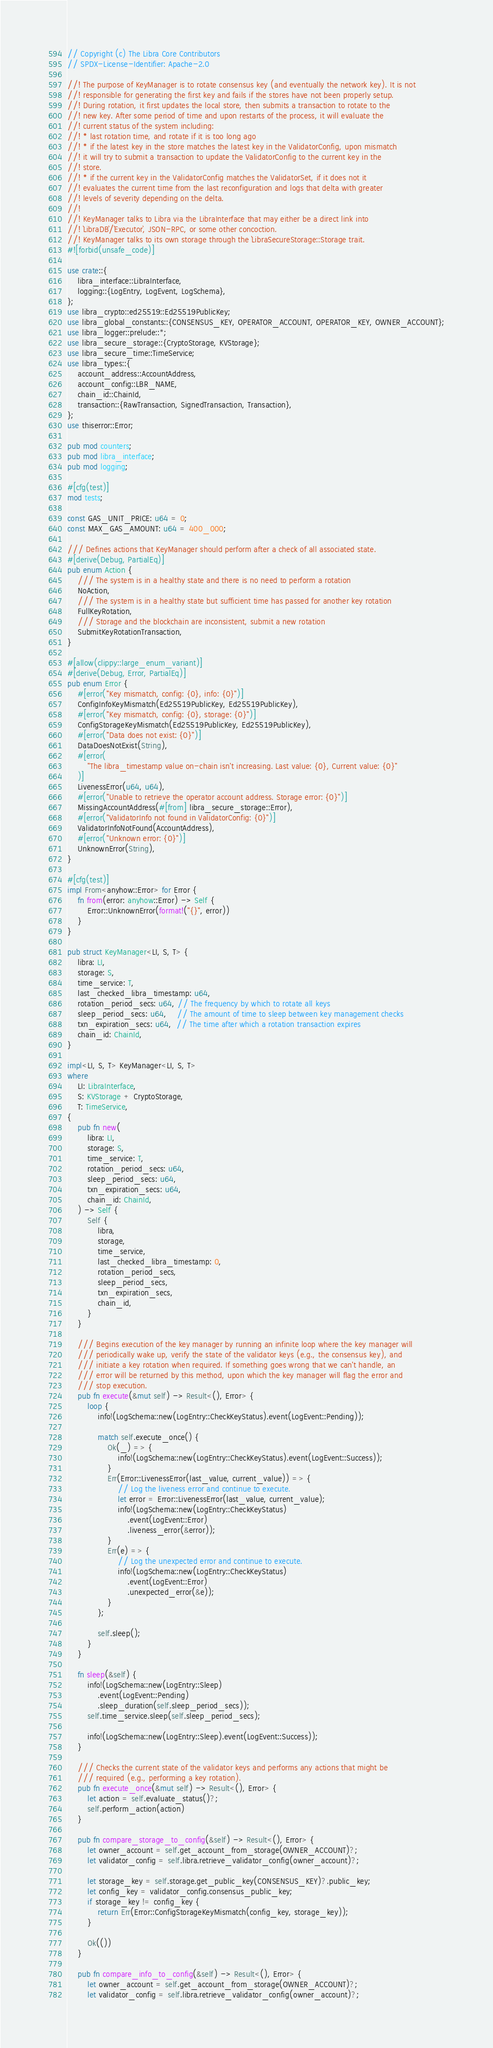<code> <loc_0><loc_0><loc_500><loc_500><_Rust_>// Copyright (c) The Libra Core Contributors
// SPDX-License-Identifier: Apache-2.0

//! The purpose of KeyManager is to rotate consensus key (and eventually the network key). It is not
//! responsible for generating the first key and fails if the stores have not been properly setup.
//! During rotation, it first updates the local store, then submits a transaction to rotate to the
//! new key. After some period of time and upon restarts of the process, it will evaluate the
//! current status of the system including:
//! * last rotation time, and rotate if it is too long ago
//! * if the latest key in the store matches the latest key in the ValidatorConfig, upon mismatch
//! it will try to submit a transaction to update the ValidatorConfig to the current key in the
//! store.
//! * if the current key in the ValidatorConfig matches the ValidatorSet, if it does not it
//! evaluates the current time from the last reconfiguration and logs that delta with greater
//! levels of severity depending on the delta.
//!
//! KeyManager talks to Libra via the LibraInterface that may either be a direct link into
//! `LibraDB`/`Executor`, JSON-RPC, or some other concoction.
//! KeyManager talks to its own storage through the `LibraSecureStorage::Storage trait.
#![forbid(unsafe_code)]

use crate::{
    libra_interface::LibraInterface,
    logging::{LogEntry, LogEvent, LogSchema},
};
use libra_crypto::ed25519::Ed25519PublicKey;
use libra_global_constants::{CONSENSUS_KEY, OPERATOR_ACCOUNT, OPERATOR_KEY, OWNER_ACCOUNT};
use libra_logger::prelude::*;
use libra_secure_storage::{CryptoStorage, KVStorage};
use libra_secure_time::TimeService;
use libra_types::{
    account_address::AccountAddress,
    account_config::LBR_NAME,
    chain_id::ChainId,
    transaction::{RawTransaction, SignedTransaction, Transaction},
};
use thiserror::Error;

pub mod counters;
pub mod libra_interface;
pub mod logging;

#[cfg(test)]
mod tests;

const GAS_UNIT_PRICE: u64 = 0;
const MAX_GAS_AMOUNT: u64 = 400_000;

/// Defines actions that KeyManager should perform after a check of all associated state.
#[derive(Debug, PartialEq)]
pub enum Action {
    /// The system is in a healthy state and there is no need to perform a rotation
    NoAction,
    /// The system is in a healthy state but sufficient time has passed for another key rotation
    FullKeyRotation,
    /// Storage and the blockchain are inconsistent, submit a new rotation
    SubmitKeyRotationTransaction,
}

#[allow(clippy::large_enum_variant)]
#[derive(Debug, Error, PartialEq)]
pub enum Error {
    #[error("Key mismatch, config: {0}, info: {0}")]
    ConfigInfoKeyMismatch(Ed25519PublicKey, Ed25519PublicKey),
    #[error("Key mismatch, config: {0}, storage: {0}")]
    ConfigStorageKeyMismatch(Ed25519PublicKey, Ed25519PublicKey),
    #[error("Data does not exist: {0}")]
    DataDoesNotExist(String),
    #[error(
        "The libra_timestamp value on-chain isn't increasing. Last value: {0}, Current value: {0}"
    )]
    LivenessError(u64, u64),
    #[error("Unable to retrieve the operator account address. Storage error: {0}")]
    MissingAccountAddress(#[from] libra_secure_storage::Error),
    #[error("ValidatorInfo not found in ValidatorConfig: {0}")]
    ValidatorInfoNotFound(AccountAddress),
    #[error("Unknown error: {0}")]
    UnknownError(String),
}

#[cfg(test)]
impl From<anyhow::Error> for Error {
    fn from(error: anyhow::Error) -> Self {
        Error::UnknownError(format!("{}", error))
    }
}

pub struct KeyManager<LI, S, T> {
    libra: LI,
    storage: S,
    time_service: T,
    last_checked_libra_timestamp: u64,
    rotation_period_secs: u64, // The frequency by which to rotate all keys
    sleep_period_secs: u64,    // The amount of time to sleep between key management checks
    txn_expiration_secs: u64,  // The time after which a rotation transaction expires
    chain_id: ChainId,
}

impl<LI, S, T> KeyManager<LI, S, T>
where
    LI: LibraInterface,
    S: KVStorage + CryptoStorage,
    T: TimeService,
{
    pub fn new(
        libra: LI,
        storage: S,
        time_service: T,
        rotation_period_secs: u64,
        sleep_period_secs: u64,
        txn_expiration_secs: u64,
        chain_id: ChainId,
    ) -> Self {
        Self {
            libra,
            storage,
            time_service,
            last_checked_libra_timestamp: 0,
            rotation_period_secs,
            sleep_period_secs,
            txn_expiration_secs,
            chain_id,
        }
    }

    /// Begins execution of the key manager by running an infinite loop where the key manager will
    /// periodically wake up, verify the state of the validator keys (e.g., the consensus key), and
    /// initiate a key rotation when required. If something goes wrong that we can't handle, an
    /// error will be returned by this method, upon which the key manager will flag the error and
    /// stop execution.
    pub fn execute(&mut self) -> Result<(), Error> {
        loop {
            info!(LogSchema::new(LogEntry::CheckKeyStatus).event(LogEvent::Pending));

            match self.execute_once() {
                Ok(_) => {
                    info!(LogSchema::new(LogEntry::CheckKeyStatus).event(LogEvent::Success));
                }
                Err(Error::LivenessError(last_value, current_value)) => {
                    // Log the liveness error and continue to execute.
                    let error = Error::LivenessError(last_value, current_value);
                    info!(LogSchema::new(LogEntry::CheckKeyStatus)
                        .event(LogEvent::Error)
                        .liveness_error(&error));
                }
                Err(e) => {
                    // Log the unexpected error and continue to execute.
                    info!(LogSchema::new(LogEntry::CheckKeyStatus)
                        .event(LogEvent::Error)
                        .unexpected_error(&e));
                }
            };

            self.sleep();
        }
    }

    fn sleep(&self) {
        info!(LogSchema::new(LogEntry::Sleep)
            .event(LogEvent::Pending)
            .sleep_duration(self.sleep_period_secs));
        self.time_service.sleep(self.sleep_period_secs);

        info!(LogSchema::new(LogEntry::Sleep).event(LogEvent::Success));
    }

    /// Checks the current state of the validator keys and performs any actions that might be
    /// required (e.g., performing a key rotation).
    pub fn execute_once(&mut self) -> Result<(), Error> {
        let action = self.evaluate_status()?;
        self.perform_action(action)
    }

    pub fn compare_storage_to_config(&self) -> Result<(), Error> {
        let owner_account = self.get_account_from_storage(OWNER_ACCOUNT)?;
        let validator_config = self.libra.retrieve_validator_config(owner_account)?;

        let storage_key = self.storage.get_public_key(CONSENSUS_KEY)?.public_key;
        let config_key = validator_config.consensus_public_key;
        if storage_key != config_key {
            return Err(Error::ConfigStorageKeyMismatch(config_key, storage_key));
        }

        Ok(())
    }

    pub fn compare_info_to_config(&self) -> Result<(), Error> {
        let owner_account = self.get_account_from_storage(OWNER_ACCOUNT)?;
        let validator_config = self.libra.retrieve_validator_config(owner_account)?;</code> 